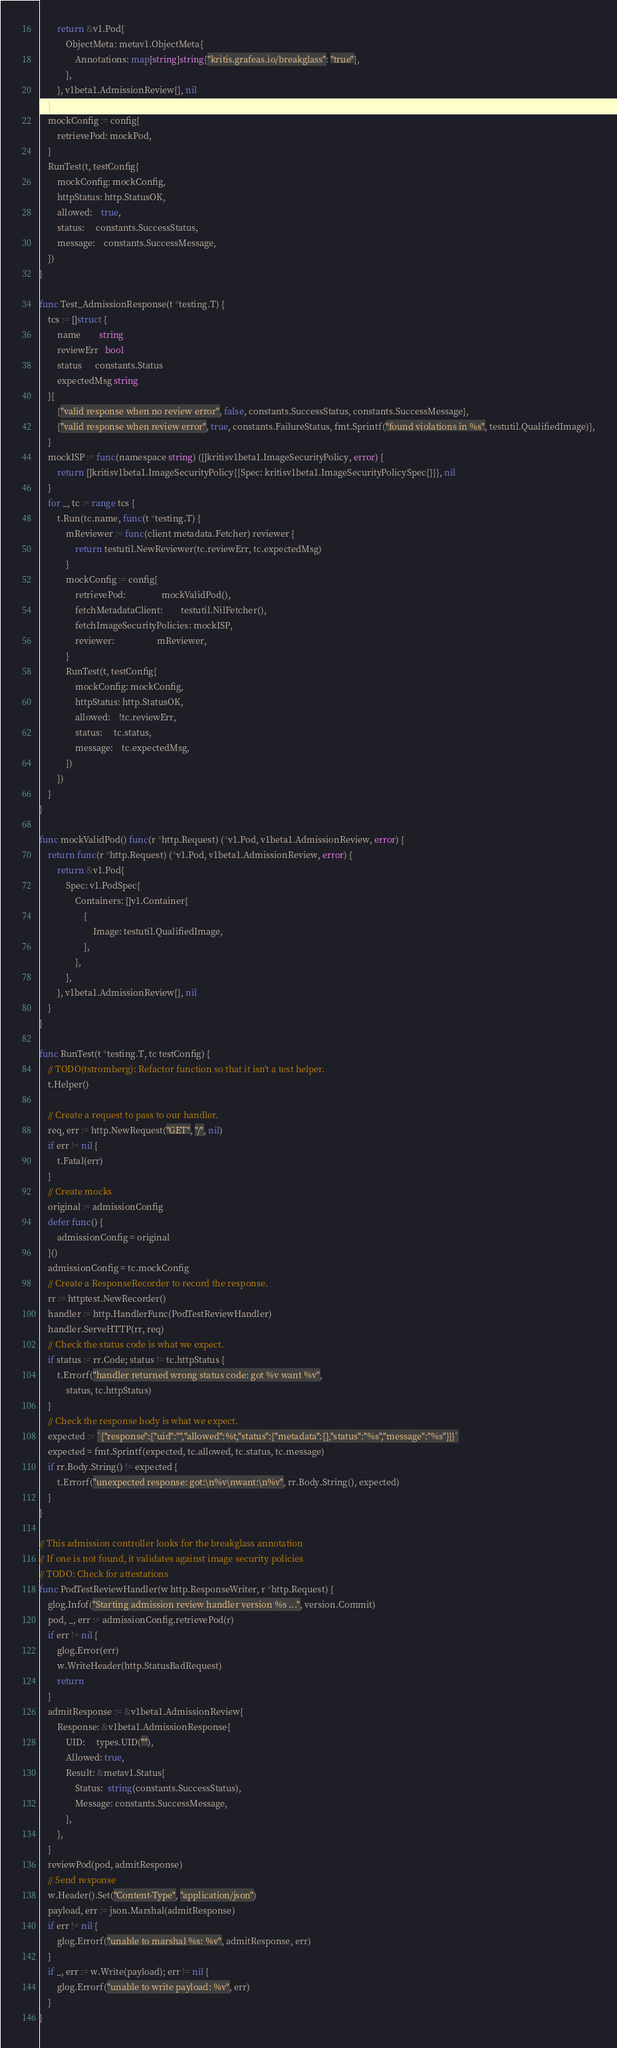Convert code to text. <code><loc_0><loc_0><loc_500><loc_500><_Go_>		return &v1.Pod{
			ObjectMeta: metav1.ObjectMeta{
				Annotations: map[string]string{"kritis.grafeas.io/breakglass": "true"},
			},
		}, v1beta1.AdmissionReview{}, nil
	}
	mockConfig := config{
		retrievePod: mockPod,
	}
	RunTest(t, testConfig{
		mockConfig: mockConfig,
		httpStatus: http.StatusOK,
		allowed:    true,
		status:     constants.SuccessStatus,
		message:    constants.SuccessMessage,
	})
}

func Test_AdmissionResponse(t *testing.T) {
	tcs := []struct {
		name        string
		reviewErr   bool
		status      constants.Status
		expectedMsg string
	}{
		{"valid response when no review error", false, constants.SuccessStatus, constants.SuccessMessage},
		{"valid response when review error", true, constants.FailureStatus, fmt.Sprintf("found violations in %s", testutil.QualifiedImage)},
	}
	mockISP := func(namespace string) ([]kritisv1beta1.ImageSecurityPolicy, error) {
		return []kritisv1beta1.ImageSecurityPolicy{{Spec: kritisv1beta1.ImageSecurityPolicySpec{}}}, nil
	}
	for _, tc := range tcs {
		t.Run(tc.name, func(t *testing.T) {
			mReviewer := func(client metadata.Fetcher) reviewer {
				return testutil.NewReviewer(tc.reviewErr, tc.expectedMsg)
			}
			mockConfig := config{
				retrievePod:                mockValidPod(),
				fetchMetadataClient:        testutil.NilFetcher(),
				fetchImageSecurityPolicies: mockISP,
				reviewer:                   mReviewer,
			}
			RunTest(t, testConfig{
				mockConfig: mockConfig,
				httpStatus: http.StatusOK,
				allowed:    !tc.reviewErr,
				status:     tc.status,
				message:    tc.expectedMsg,
			})
		})
	}
}

func mockValidPod() func(r *http.Request) (*v1.Pod, v1beta1.AdmissionReview, error) {
	return func(r *http.Request) (*v1.Pod, v1beta1.AdmissionReview, error) {
		return &v1.Pod{
			Spec: v1.PodSpec{
				Containers: []v1.Container{
					{
						Image: testutil.QualifiedImage,
					},
				},
			},
		}, v1beta1.AdmissionReview{}, nil
	}
}

func RunTest(t *testing.T, tc testConfig) {
	// TODO(tstromberg): Refactor function so that it isn't a test helper.
	t.Helper()

	// Create a request to pass to our handler.
	req, err := http.NewRequest("GET", "/", nil)
	if err != nil {
		t.Fatal(err)
	}
	// Create mocks
	original := admissionConfig
	defer func() {
		admissionConfig = original
	}()
	admissionConfig = tc.mockConfig
	// Create a ResponseRecorder to record the response.
	rr := httptest.NewRecorder()
	handler := http.HandlerFunc(PodTestReviewHandler)
	handler.ServeHTTP(rr, req)
	// Check the status code is what we expect.
	if status := rr.Code; status != tc.httpStatus {
		t.Errorf("handler returned wrong status code: got %v want %v",
			status, tc.httpStatus)
	}
	// Check the response body is what we expect.
	expected := `{"response":{"uid":"","allowed":%t,"status":{"metadata":{},"status":"%s","message":"%s"}}}`
	expected = fmt.Sprintf(expected, tc.allowed, tc.status, tc.message)
	if rr.Body.String() != expected {
		t.Errorf("unexpected response: got:\n%v\nwant:\n%v", rr.Body.String(), expected)
	}
}

// This admission controller looks for the breakglass annotation
// If one is not found, it validates against image security policies
// TODO: Check for attestations
func PodTestReviewHandler(w http.ResponseWriter, r *http.Request) {
	glog.Infof("Starting admission review handler version %s ...", version.Commit)
	pod, _, err := admissionConfig.retrievePod(r)
	if err != nil {
		glog.Error(err)
		w.WriteHeader(http.StatusBadRequest)
		return
	}
	admitResponse := &v1beta1.AdmissionReview{
		Response: &v1beta1.AdmissionResponse{
			UID:     types.UID(""),
			Allowed: true,
			Result: &metav1.Status{
				Status:  string(constants.SuccessStatus),
				Message: constants.SuccessMessage,
			},
		},
	}
	reviewPod(pod, admitResponse)
	// Send response
	w.Header().Set("Content-Type", "application/json")
	payload, err := json.Marshal(admitResponse)
	if err != nil {
		glog.Errorf("unable to marshal %s: %v", admitResponse, err)
	}
	if _, err := w.Write(payload); err != nil {
		glog.Errorf("unable to write payload: %v", err)
	}
}
</code> 